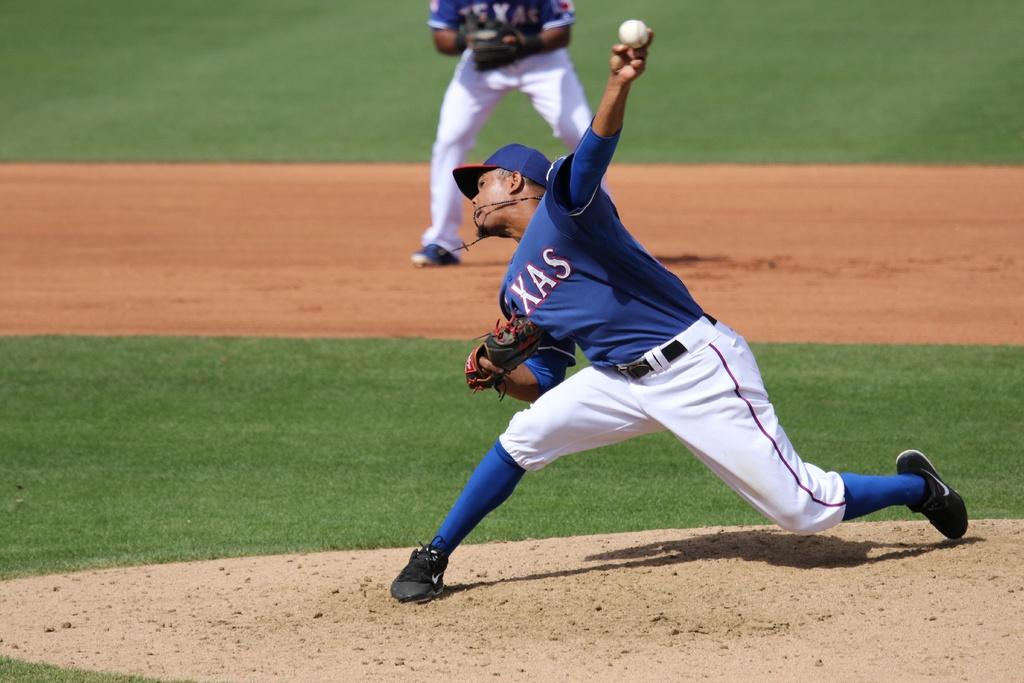<image>
Share a concise interpretation of the image provided. A pitcher for the Texas rangers is almost ready to release the ball. 